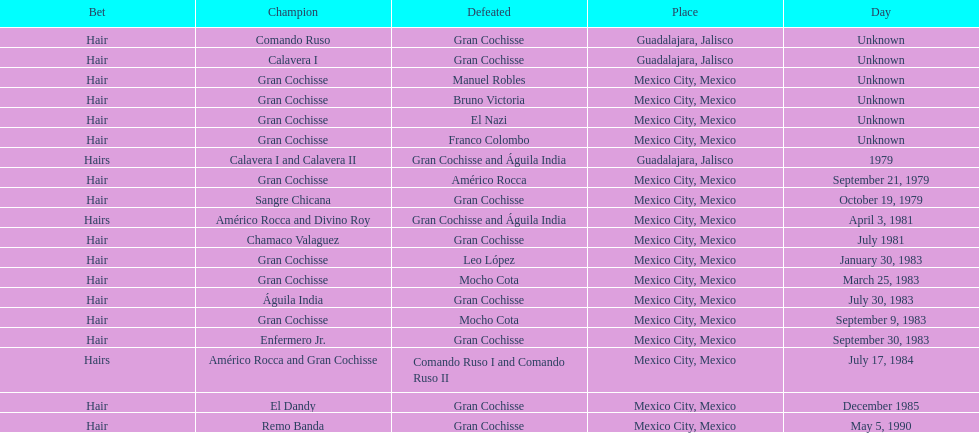When did bruno victoria lose his first game? Unknown. 